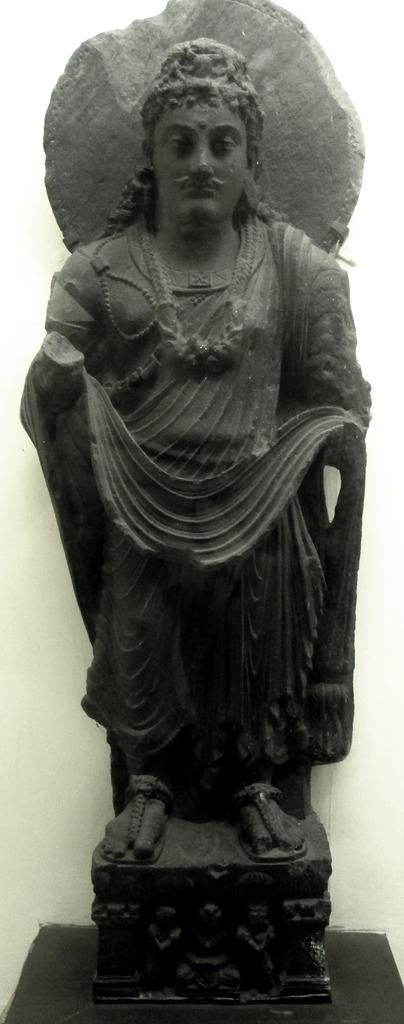What type of material is the sculpture made of in the image? The sculpture is made of rock in the image. Where is the sculpture located? The sculpture is on a desk in the image. What is the color of the sculpture? The sculpture is black in color. What can be seen in the background of the image? There is a wall in the background of the image. What type of crack is visible on the sculpture in the image? There is no crack visible on the sculpture in the image. Is there a crib present in the image? No, there is no crib present in the image. 